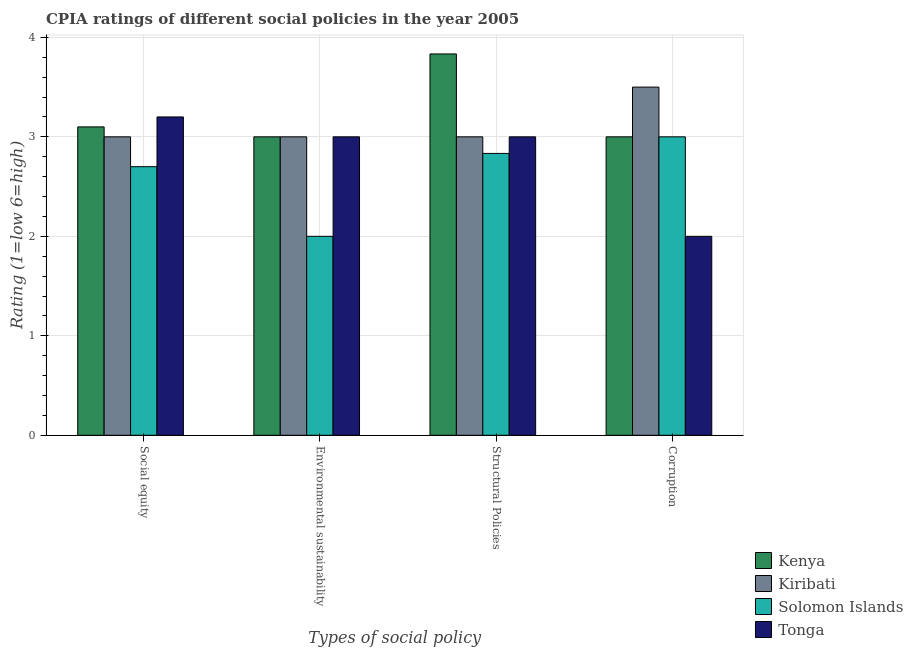Are the number of bars per tick equal to the number of legend labels?
Your answer should be very brief. Yes. How many bars are there on the 4th tick from the left?
Your answer should be compact. 4. What is the label of the 4th group of bars from the left?
Keep it short and to the point. Corruption. Across all countries, what is the minimum cpia rating of corruption?
Offer a very short reply. 2. In which country was the cpia rating of environmental sustainability maximum?
Give a very brief answer. Kenya. In which country was the cpia rating of social equity minimum?
Your answer should be compact. Solomon Islands. What is the total cpia rating of structural policies in the graph?
Provide a short and direct response. 12.67. What is the difference between the cpia rating of corruption in Kenya and the cpia rating of social equity in Tonga?
Make the answer very short. -0.2. What is the average cpia rating of environmental sustainability per country?
Ensure brevity in your answer.  2.75. What is the difference between the cpia rating of structural policies and cpia rating of social equity in Kiribati?
Ensure brevity in your answer.  0. In how many countries, is the cpia rating of corruption greater than 0.4 ?
Give a very brief answer. 4. What is the ratio of the cpia rating of social equity in Solomon Islands to that in Kenya?
Keep it short and to the point. 0.87. Is the difference between the cpia rating of environmental sustainability in Solomon Islands and Tonga greater than the difference between the cpia rating of social equity in Solomon Islands and Tonga?
Keep it short and to the point. No. What is the difference between the highest and the second highest cpia rating of structural policies?
Keep it short and to the point. 0.83. What is the difference between the highest and the lowest cpia rating of structural policies?
Offer a very short reply. 1. Is the sum of the cpia rating of structural policies in Kenya and Kiribati greater than the maximum cpia rating of environmental sustainability across all countries?
Your answer should be compact. Yes. Is it the case that in every country, the sum of the cpia rating of social equity and cpia rating of structural policies is greater than the sum of cpia rating of corruption and cpia rating of environmental sustainability?
Make the answer very short. No. What does the 1st bar from the left in Environmental sustainability represents?
Give a very brief answer. Kenya. What does the 3rd bar from the right in Corruption represents?
Provide a succinct answer. Kiribati. Is it the case that in every country, the sum of the cpia rating of social equity and cpia rating of environmental sustainability is greater than the cpia rating of structural policies?
Provide a short and direct response. Yes. How many bars are there?
Offer a terse response. 16. Are all the bars in the graph horizontal?
Give a very brief answer. No. What is the difference between two consecutive major ticks on the Y-axis?
Your answer should be very brief. 1. Does the graph contain any zero values?
Keep it short and to the point. No. Does the graph contain grids?
Keep it short and to the point. Yes. What is the title of the graph?
Make the answer very short. CPIA ratings of different social policies in the year 2005. Does "Nicaragua" appear as one of the legend labels in the graph?
Offer a terse response. No. What is the label or title of the X-axis?
Ensure brevity in your answer.  Types of social policy. What is the label or title of the Y-axis?
Your answer should be compact. Rating (1=low 6=high). What is the Rating (1=low 6=high) of Kenya in Social equity?
Ensure brevity in your answer.  3.1. What is the Rating (1=low 6=high) in Kiribati in Social equity?
Provide a succinct answer. 3. What is the Rating (1=low 6=high) in Tonga in Social equity?
Your response must be concise. 3.2. What is the Rating (1=low 6=high) in Kiribati in Environmental sustainability?
Give a very brief answer. 3. What is the Rating (1=low 6=high) of Kenya in Structural Policies?
Your answer should be compact. 3.83. What is the Rating (1=low 6=high) in Solomon Islands in Structural Policies?
Ensure brevity in your answer.  2.83. What is the Rating (1=low 6=high) of Kiribati in Corruption?
Ensure brevity in your answer.  3.5. What is the Rating (1=low 6=high) in Solomon Islands in Corruption?
Give a very brief answer. 3. Across all Types of social policy, what is the maximum Rating (1=low 6=high) in Kenya?
Your answer should be compact. 3.83. Across all Types of social policy, what is the maximum Rating (1=low 6=high) in Kiribati?
Keep it short and to the point. 3.5. Across all Types of social policy, what is the minimum Rating (1=low 6=high) in Kenya?
Provide a short and direct response. 3. Across all Types of social policy, what is the minimum Rating (1=low 6=high) in Kiribati?
Your answer should be very brief. 3. Across all Types of social policy, what is the minimum Rating (1=low 6=high) of Tonga?
Your response must be concise. 2. What is the total Rating (1=low 6=high) in Kenya in the graph?
Provide a short and direct response. 12.93. What is the total Rating (1=low 6=high) of Kiribati in the graph?
Ensure brevity in your answer.  12.5. What is the total Rating (1=low 6=high) in Solomon Islands in the graph?
Offer a terse response. 10.53. What is the total Rating (1=low 6=high) of Tonga in the graph?
Your answer should be very brief. 11.2. What is the difference between the Rating (1=low 6=high) in Solomon Islands in Social equity and that in Environmental sustainability?
Offer a very short reply. 0.7. What is the difference between the Rating (1=low 6=high) in Tonga in Social equity and that in Environmental sustainability?
Offer a terse response. 0.2. What is the difference between the Rating (1=low 6=high) in Kenya in Social equity and that in Structural Policies?
Give a very brief answer. -0.73. What is the difference between the Rating (1=low 6=high) in Kiribati in Social equity and that in Structural Policies?
Provide a short and direct response. 0. What is the difference between the Rating (1=low 6=high) in Solomon Islands in Social equity and that in Structural Policies?
Keep it short and to the point. -0.13. What is the difference between the Rating (1=low 6=high) in Tonga in Social equity and that in Structural Policies?
Offer a terse response. 0.2. What is the difference between the Rating (1=low 6=high) in Kenya in Environmental sustainability and that in Structural Policies?
Provide a short and direct response. -0.83. What is the difference between the Rating (1=low 6=high) in Kiribati in Environmental sustainability and that in Corruption?
Your response must be concise. -0.5. What is the difference between the Rating (1=low 6=high) in Kenya in Structural Policies and that in Corruption?
Offer a terse response. 0.83. What is the difference between the Rating (1=low 6=high) in Tonga in Structural Policies and that in Corruption?
Your response must be concise. 1. What is the difference between the Rating (1=low 6=high) of Kenya in Social equity and the Rating (1=low 6=high) of Kiribati in Environmental sustainability?
Offer a very short reply. 0.1. What is the difference between the Rating (1=low 6=high) of Kenya in Social equity and the Rating (1=low 6=high) of Tonga in Environmental sustainability?
Provide a short and direct response. 0.1. What is the difference between the Rating (1=low 6=high) of Kiribati in Social equity and the Rating (1=low 6=high) of Tonga in Environmental sustainability?
Provide a short and direct response. 0. What is the difference between the Rating (1=low 6=high) in Solomon Islands in Social equity and the Rating (1=low 6=high) in Tonga in Environmental sustainability?
Ensure brevity in your answer.  -0.3. What is the difference between the Rating (1=low 6=high) in Kenya in Social equity and the Rating (1=low 6=high) in Kiribati in Structural Policies?
Make the answer very short. 0.1. What is the difference between the Rating (1=low 6=high) in Kenya in Social equity and the Rating (1=low 6=high) in Solomon Islands in Structural Policies?
Provide a succinct answer. 0.27. What is the difference between the Rating (1=low 6=high) in Solomon Islands in Social equity and the Rating (1=low 6=high) in Tonga in Structural Policies?
Offer a very short reply. -0.3. What is the difference between the Rating (1=low 6=high) in Kenya in Social equity and the Rating (1=low 6=high) in Kiribati in Corruption?
Make the answer very short. -0.4. What is the difference between the Rating (1=low 6=high) of Kiribati in Social equity and the Rating (1=low 6=high) of Tonga in Corruption?
Make the answer very short. 1. What is the difference between the Rating (1=low 6=high) of Kenya in Environmental sustainability and the Rating (1=low 6=high) of Solomon Islands in Structural Policies?
Provide a succinct answer. 0.17. What is the difference between the Rating (1=low 6=high) of Kenya in Environmental sustainability and the Rating (1=low 6=high) of Kiribati in Corruption?
Make the answer very short. -0.5. What is the difference between the Rating (1=low 6=high) of Kenya in Environmental sustainability and the Rating (1=low 6=high) of Solomon Islands in Corruption?
Give a very brief answer. 0. What is the difference between the Rating (1=low 6=high) in Kiribati in Environmental sustainability and the Rating (1=low 6=high) in Solomon Islands in Corruption?
Give a very brief answer. 0. What is the difference between the Rating (1=low 6=high) of Kiribati in Environmental sustainability and the Rating (1=low 6=high) of Tonga in Corruption?
Your response must be concise. 1. What is the difference between the Rating (1=low 6=high) of Kenya in Structural Policies and the Rating (1=low 6=high) of Tonga in Corruption?
Make the answer very short. 1.83. What is the difference between the Rating (1=low 6=high) of Kiribati in Structural Policies and the Rating (1=low 6=high) of Tonga in Corruption?
Provide a succinct answer. 1. What is the average Rating (1=low 6=high) in Kenya per Types of social policy?
Offer a terse response. 3.23. What is the average Rating (1=low 6=high) in Kiribati per Types of social policy?
Your response must be concise. 3.12. What is the average Rating (1=low 6=high) in Solomon Islands per Types of social policy?
Keep it short and to the point. 2.63. What is the average Rating (1=low 6=high) of Tonga per Types of social policy?
Offer a terse response. 2.8. What is the difference between the Rating (1=low 6=high) in Kenya and Rating (1=low 6=high) in Kiribati in Social equity?
Keep it short and to the point. 0.1. What is the difference between the Rating (1=low 6=high) in Kenya and Rating (1=low 6=high) in Tonga in Social equity?
Your response must be concise. -0.1. What is the difference between the Rating (1=low 6=high) in Kiribati and Rating (1=low 6=high) in Solomon Islands in Social equity?
Make the answer very short. 0.3. What is the difference between the Rating (1=low 6=high) of Solomon Islands and Rating (1=low 6=high) of Tonga in Social equity?
Offer a very short reply. -0.5. What is the difference between the Rating (1=low 6=high) of Kenya and Rating (1=low 6=high) of Kiribati in Environmental sustainability?
Offer a terse response. 0. What is the difference between the Rating (1=low 6=high) in Kiribati and Rating (1=low 6=high) in Tonga in Environmental sustainability?
Keep it short and to the point. 0. What is the difference between the Rating (1=low 6=high) of Solomon Islands and Rating (1=low 6=high) of Tonga in Environmental sustainability?
Give a very brief answer. -1. What is the difference between the Rating (1=low 6=high) in Kenya and Rating (1=low 6=high) in Kiribati in Structural Policies?
Offer a terse response. 0.83. What is the difference between the Rating (1=low 6=high) of Kenya and Rating (1=low 6=high) of Solomon Islands in Structural Policies?
Ensure brevity in your answer.  1. What is the difference between the Rating (1=low 6=high) of Kiribati and Rating (1=low 6=high) of Solomon Islands in Structural Policies?
Give a very brief answer. 0.17. What is the difference between the Rating (1=low 6=high) in Solomon Islands and Rating (1=low 6=high) in Tonga in Structural Policies?
Ensure brevity in your answer.  -0.17. What is the difference between the Rating (1=low 6=high) of Kenya and Rating (1=low 6=high) of Kiribati in Corruption?
Your answer should be very brief. -0.5. What is the difference between the Rating (1=low 6=high) in Kenya and Rating (1=low 6=high) in Solomon Islands in Corruption?
Ensure brevity in your answer.  0. What is the difference between the Rating (1=low 6=high) in Kenya and Rating (1=low 6=high) in Tonga in Corruption?
Provide a succinct answer. 1. What is the difference between the Rating (1=low 6=high) of Kiribati and Rating (1=low 6=high) of Solomon Islands in Corruption?
Provide a succinct answer. 0.5. What is the ratio of the Rating (1=low 6=high) in Solomon Islands in Social equity to that in Environmental sustainability?
Offer a very short reply. 1.35. What is the ratio of the Rating (1=low 6=high) in Tonga in Social equity to that in Environmental sustainability?
Provide a short and direct response. 1.07. What is the ratio of the Rating (1=low 6=high) in Kenya in Social equity to that in Structural Policies?
Ensure brevity in your answer.  0.81. What is the ratio of the Rating (1=low 6=high) of Solomon Islands in Social equity to that in Structural Policies?
Make the answer very short. 0.95. What is the ratio of the Rating (1=low 6=high) of Tonga in Social equity to that in Structural Policies?
Make the answer very short. 1.07. What is the ratio of the Rating (1=low 6=high) of Kiribati in Social equity to that in Corruption?
Keep it short and to the point. 0.86. What is the ratio of the Rating (1=low 6=high) of Kenya in Environmental sustainability to that in Structural Policies?
Keep it short and to the point. 0.78. What is the ratio of the Rating (1=low 6=high) of Kiribati in Environmental sustainability to that in Structural Policies?
Give a very brief answer. 1. What is the ratio of the Rating (1=low 6=high) of Solomon Islands in Environmental sustainability to that in Structural Policies?
Your answer should be compact. 0.71. What is the ratio of the Rating (1=low 6=high) of Kenya in Environmental sustainability to that in Corruption?
Provide a succinct answer. 1. What is the ratio of the Rating (1=low 6=high) in Kiribati in Environmental sustainability to that in Corruption?
Provide a short and direct response. 0.86. What is the ratio of the Rating (1=low 6=high) in Tonga in Environmental sustainability to that in Corruption?
Keep it short and to the point. 1.5. What is the ratio of the Rating (1=low 6=high) in Kenya in Structural Policies to that in Corruption?
Offer a terse response. 1.28. What is the ratio of the Rating (1=low 6=high) of Solomon Islands in Structural Policies to that in Corruption?
Give a very brief answer. 0.94. What is the difference between the highest and the second highest Rating (1=low 6=high) in Kenya?
Provide a succinct answer. 0.73. What is the difference between the highest and the second highest Rating (1=low 6=high) in Solomon Islands?
Your answer should be very brief. 0.17. What is the difference between the highest and the lowest Rating (1=low 6=high) of Kenya?
Your answer should be compact. 0.83. What is the difference between the highest and the lowest Rating (1=low 6=high) of Kiribati?
Your answer should be very brief. 0.5. What is the difference between the highest and the lowest Rating (1=low 6=high) of Solomon Islands?
Keep it short and to the point. 1. What is the difference between the highest and the lowest Rating (1=low 6=high) in Tonga?
Keep it short and to the point. 1.2. 